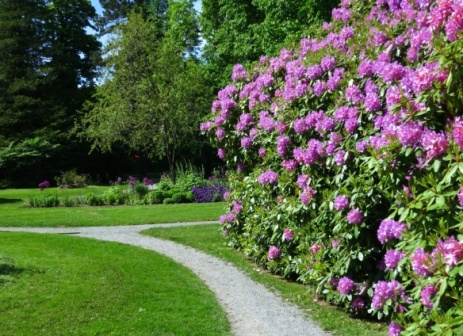Analyze the image in a comprehensive and detailed manner. The image captures a serene garden scene. A winding path, constructed from small white stones, serves as the focal point. It meanders around a large bush adorned with pink flowers, which is situated on the right side of the image and occupies approximately half of the frame. The path seems to invite onlookers on a journey around the garden, its white stones contrasting with the surrounding greenery. The garden itself is lush, filled with various green trees and shrubs that fill the background, creating a sense of depth and tranquility. The sky is not visible, suggesting the photo was taken from a perspective that focuses on the garden's landscape. The image does not contain any discernible text or human activity, further emphasizing the peacefulness of the garden. 